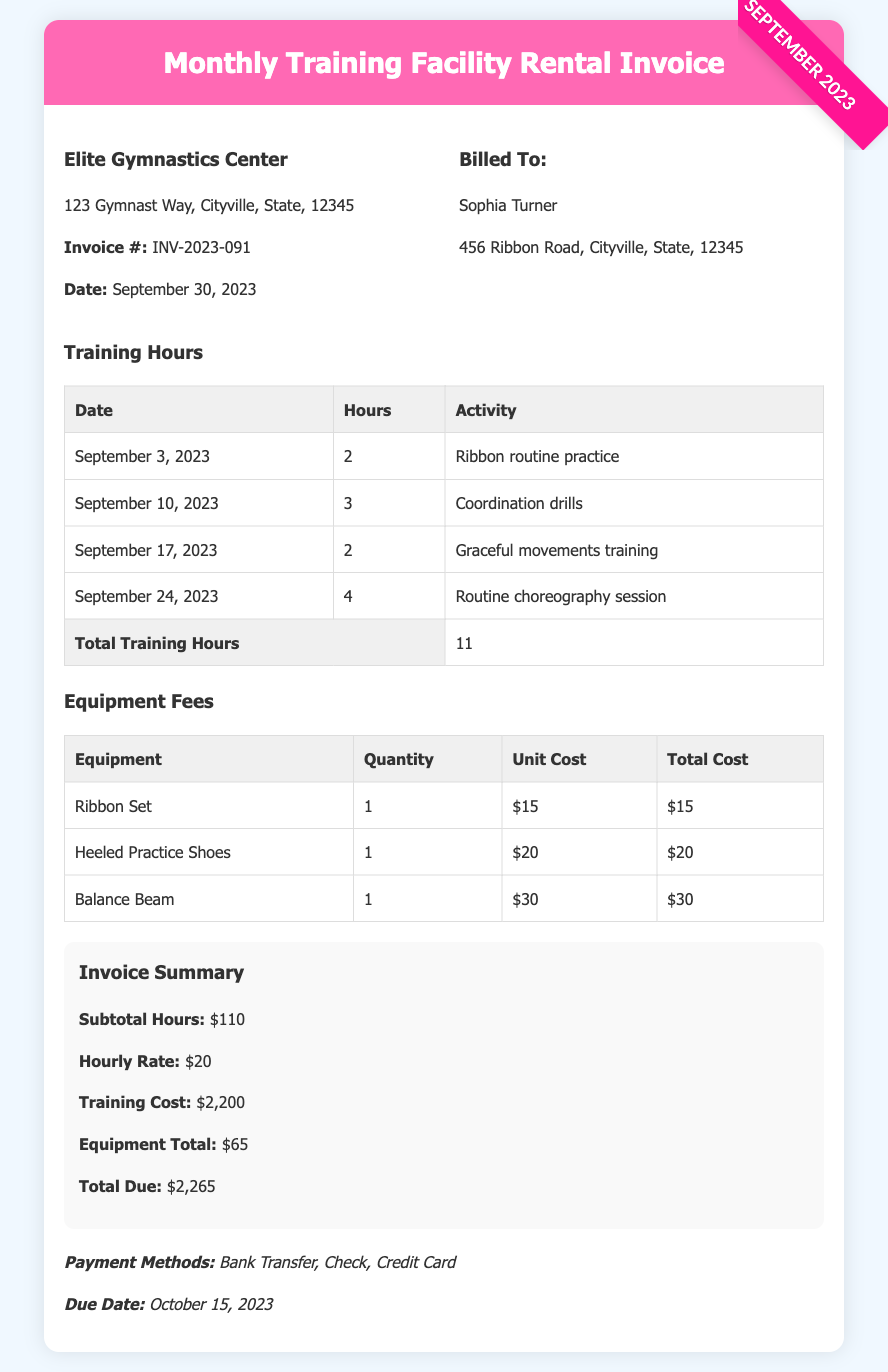What is the total number of training hours? The total training hours are listed in the table under "Total Training Hours," which is 11.
Answer: 11 What is the due date for the payment? The due date for the payment is mentioned in the "Payment Methods" section, which is October 15, 2023.
Answer: October 15, 2023 How much is the hourly rate? The hourly rate is indicated in the invoice summary, which is $20.
Answer: $20 What is the total cost for the Training? The total cost for training is provided under "Invoice Summary," which reads $2,200.
Answer: $2,200 Who is the invoice billed to? The name of the individual the invoice is billed to is listed in the document as Sophia Turner.
Answer: Sophia Turner How many Balance Beams were rented? The quantity of Balance Beams is specified in the Equipment Fees table, which shows 1.
Answer: 1 What is the total due amount? The total due is calculated and shown in the invoice summary as $2,265.
Answer: $2,265 What type of activity was practiced on September 3, 2023? The specific activity practiced on September 3, 2023, is described in the training hours table as "Ribbon routine practice."
Answer: Ribbon routine practice What is the total cost for the Ribbon Set? The total cost for the Ribbon Set is outlined in the Equipment Fees table, which is $15.
Answer: $15 